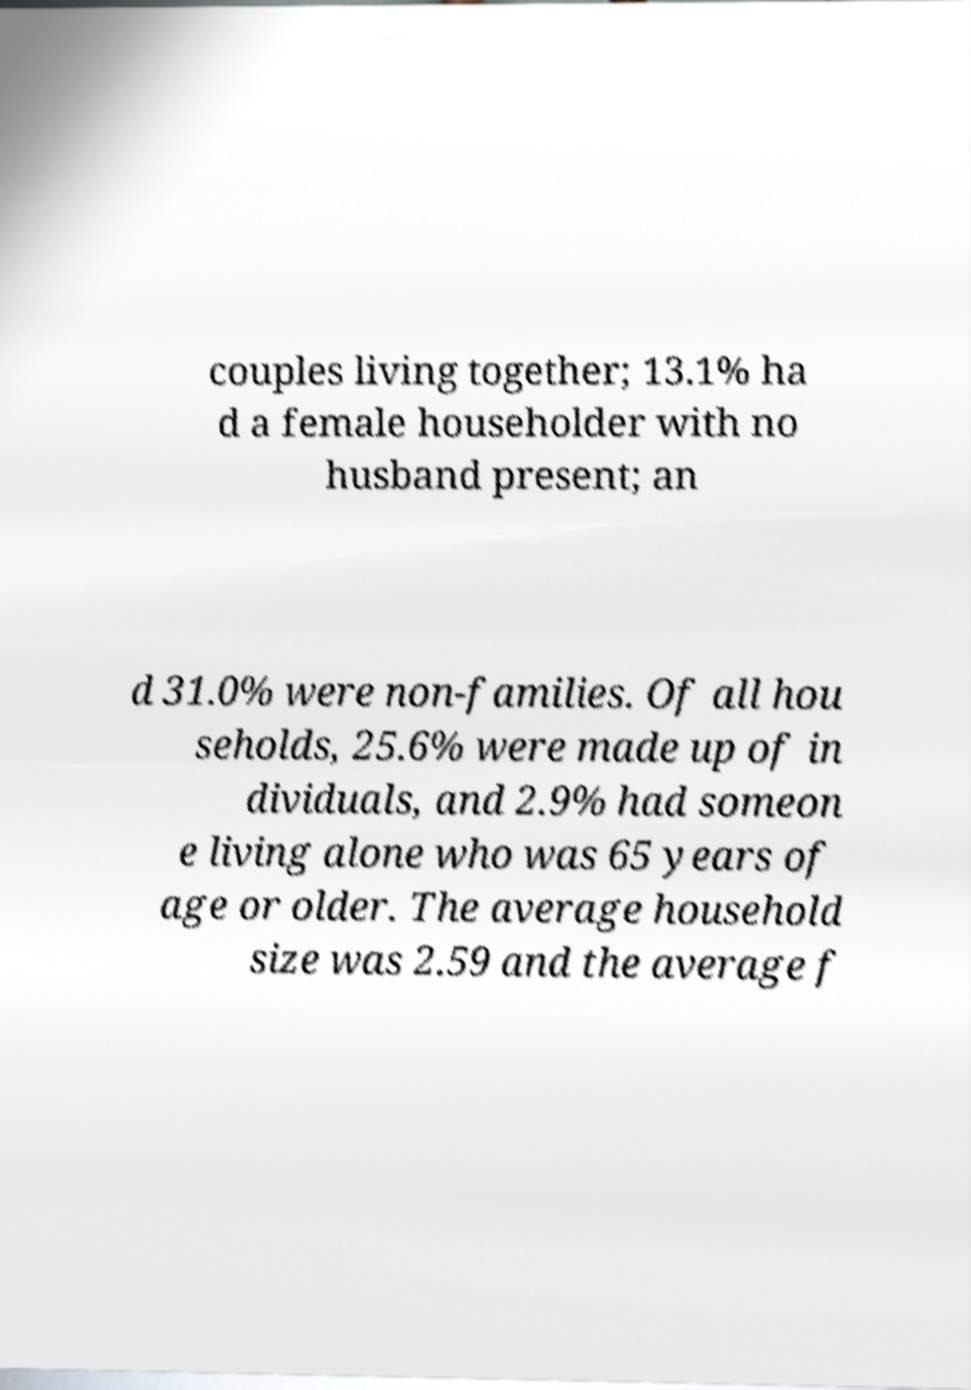For documentation purposes, I need the text within this image transcribed. Could you provide that? couples living together; 13.1% ha d a female householder with no husband present; an d 31.0% were non-families. Of all hou seholds, 25.6% were made up of in dividuals, and 2.9% had someon e living alone who was 65 years of age or older. The average household size was 2.59 and the average f 